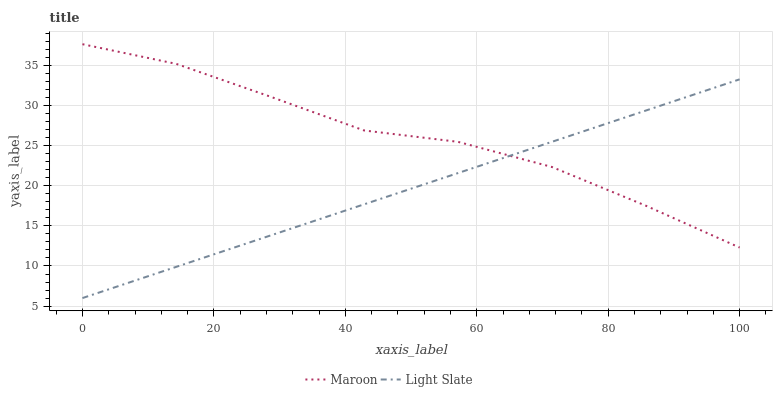Does Light Slate have the minimum area under the curve?
Answer yes or no. Yes. Does Maroon have the maximum area under the curve?
Answer yes or no. Yes. Does Maroon have the minimum area under the curve?
Answer yes or no. No. Is Light Slate the smoothest?
Answer yes or no. Yes. Is Maroon the roughest?
Answer yes or no. Yes. Is Maroon the smoothest?
Answer yes or no. No. Does Light Slate have the lowest value?
Answer yes or no. Yes. Does Maroon have the lowest value?
Answer yes or no. No. Does Maroon have the highest value?
Answer yes or no. Yes. Does Light Slate intersect Maroon?
Answer yes or no. Yes. Is Light Slate less than Maroon?
Answer yes or no. No. Is Light Slate greater than Maroon?
Answer yes or no. No. 